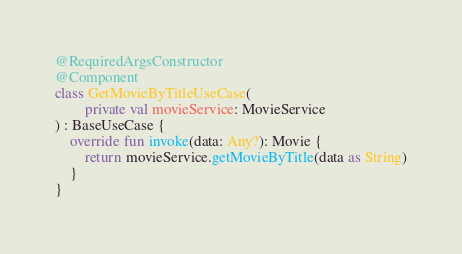<code> <loc_0><loc_0><loc_500><loc_500><_Kotlin_>@RequiredArgsConstructor
@Component
class GetMovieByTitleUseCase(
        private val movieService: MovieService
) : BaseUseCase {
    override fun invoke(data: Any?): Movie {
        return movieService.getMovieByTitle(data as String)
    }
}</code> 